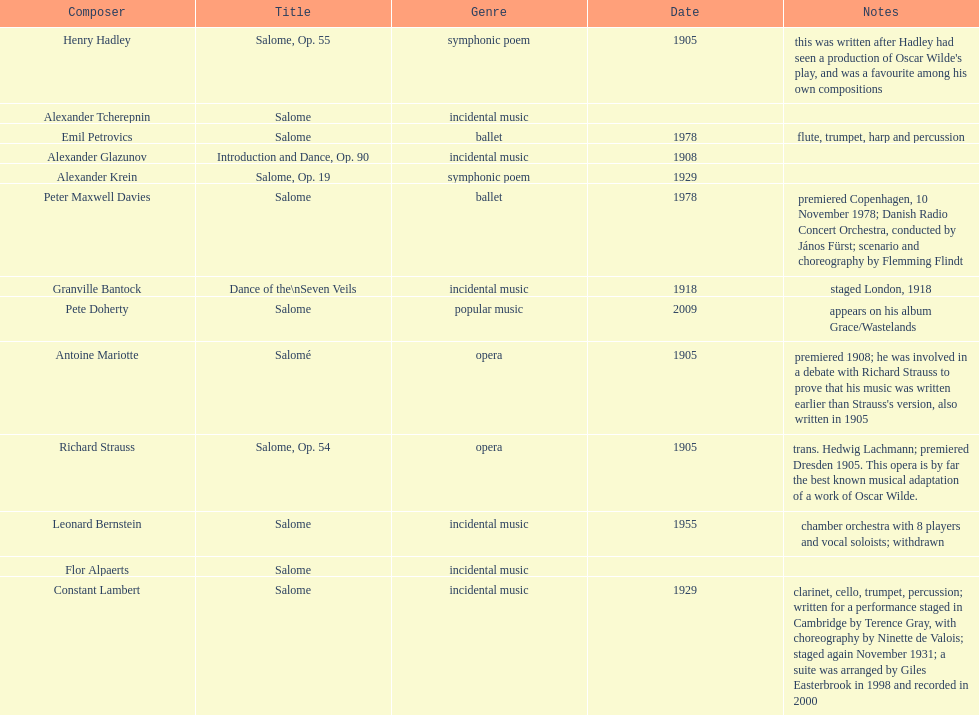How many are symphonic poems? 2. 